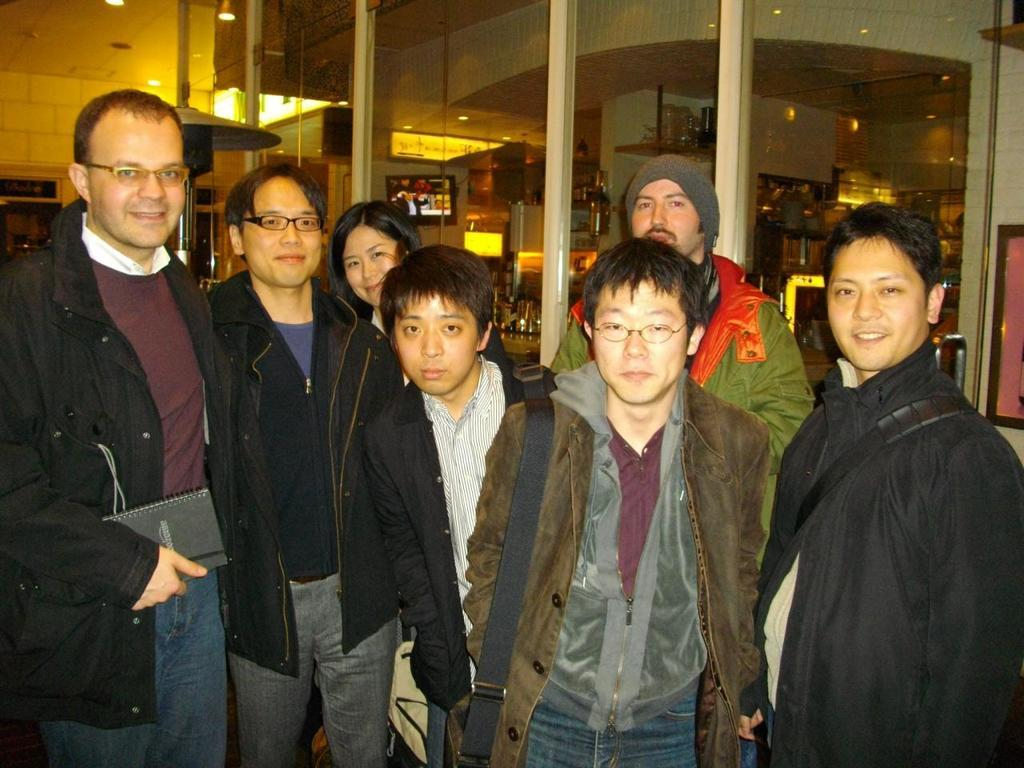What is happening in the middle of the image? There are people standing in the middle of the image. How are the people in the image feeling? The people are smiling. What can be seen in the background of the image? There is a glass wall in the background of the image. What type of spade is being used by the people in the image? There is no spade present in the image; the people are simply standing and smiling. What appliance can be seen on the glass wall in the image? There is no appliance visible on the glass wall in the image. 